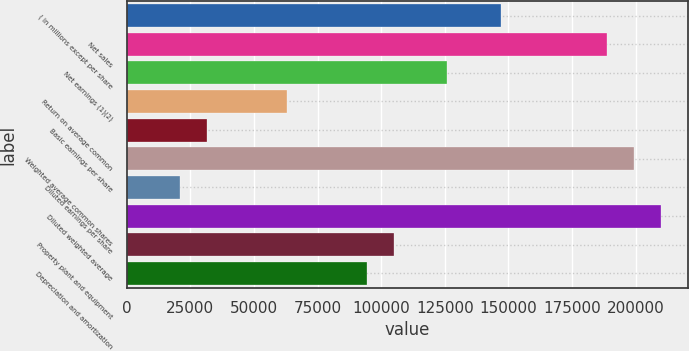Convert chart to OTSL. <chart><loc_0><loc_0><loc_500><loc_500><bar_chart><fcel>( in millions except per share<fcel>Net sales<fcel>Net earnings (1)(2)<fcel>Return on average common<fcel>Basic earnings per share<fcel>Weighted average common shares<fcel>Diluted earnings per share<fcel>Diluted weighted average<fcel>Property plant and equipment<fcel>Depreciation and amortization<nl><fcel>146931<fcel>188911<fcel>125941<fcel>62970.8<fcel>31485.6<fcel>199407<fcel>20990.5<fcel>209902<fcel>104951<fcel>94455.9<nl></chart> 